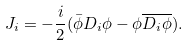<formula> <loc_0><loc_0><loc_500><loc_500>J _ { i } = - \frac { i } { 2 } ( \bar { \phi } D _ { i } \phi - \phi { \overline { D _ { i } \phi } } ) .</formula> 